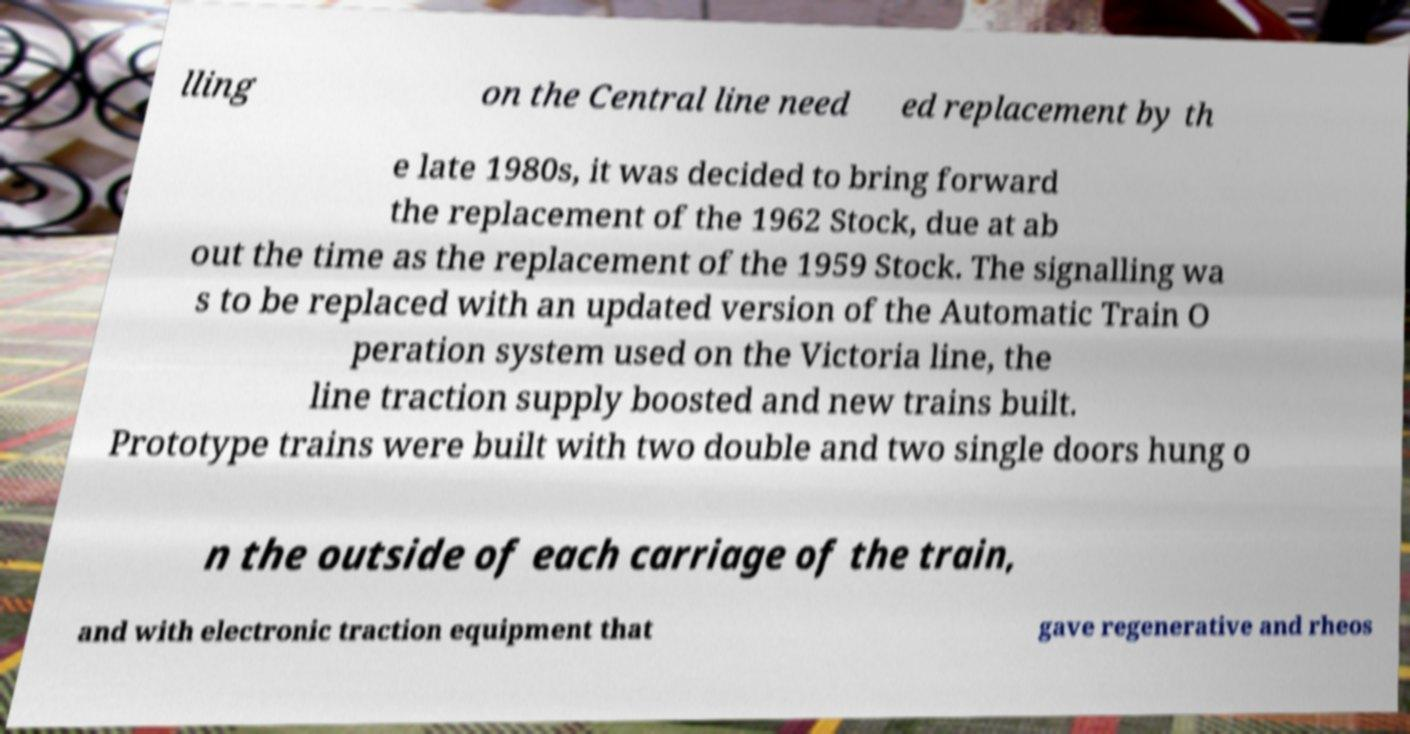For documentation purposes, I need the text within this image transcribed. Could you provide that? lling on the Central line need ed replacement by th e late 1980s, it was decided to bring forward the replacement of the 1962 Stock, due at ab out the time as the replacement of the 1959 Stock. The signalling wa s to be replaced with an updated version of the Automatic Train O peration system used on the Victoria line, the line traction supply boosted and new trains built. Prototype trains were built with two double and two single doors hung o n the outside of each carriage of the train, and with electronic traction equipment that gave regenerative and rheos 